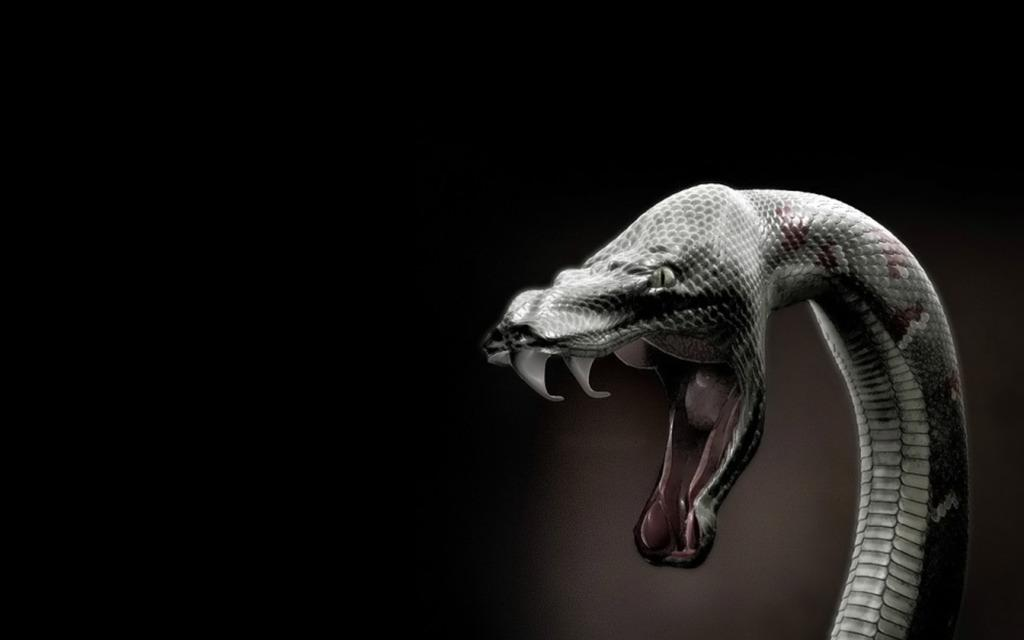What animal is present in the image? There is a snake in the image. What can be observed about the background of the image? The background of the image is dark. How many branches can be seen supporting the snake in the image? There are no branches present in the image, as it features a snake with a dark background. 